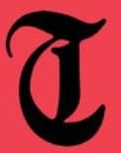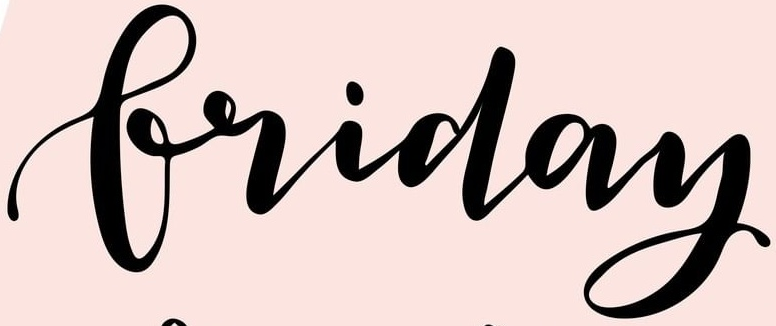What words can you see in these images in sequence, separated by a semicolon? T; Friday 